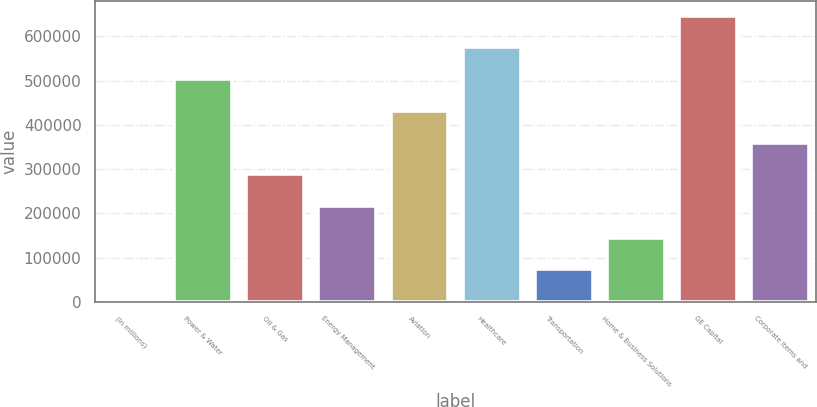Convert chart to OTSL. <chart><loc_0><loc_0><loc_500><loc_500><bar_chart><fcel>(In millions)<fcel>Power & Water<fcel>Oil & Gas<fcel>Energy Management<fcel>Aviation<fcel>Healthcare<fcel>Transportation<fcel>Home & Business Solutions<fcel>GE Capital<fcel>Corporate items and<nl><fcel>2011<fcel>503336<fcel>288482<fcel>216864<fcel>431718<fcel>574953<fcel>73628.8<fcel>145247<fcel>646571<fcel>360100<nl></chart> 